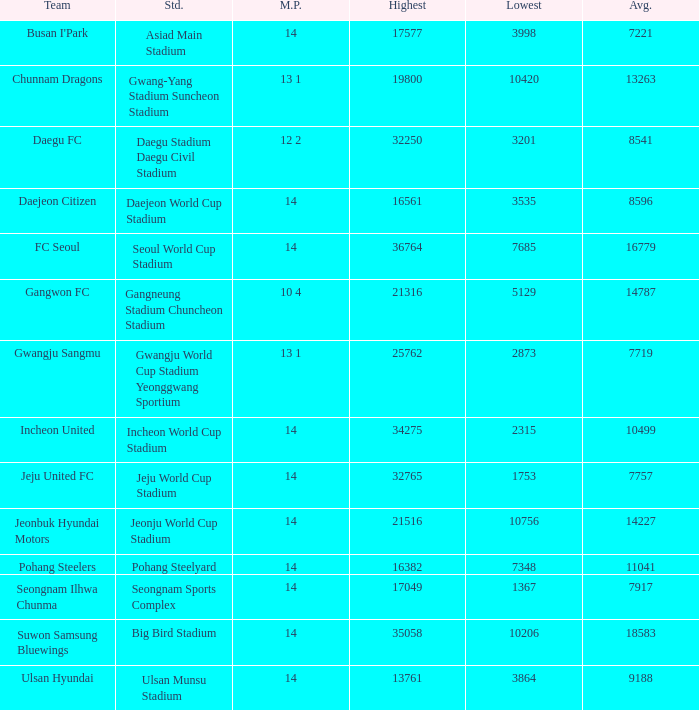Which group has 7757 as the mean? Jeju United FC. 